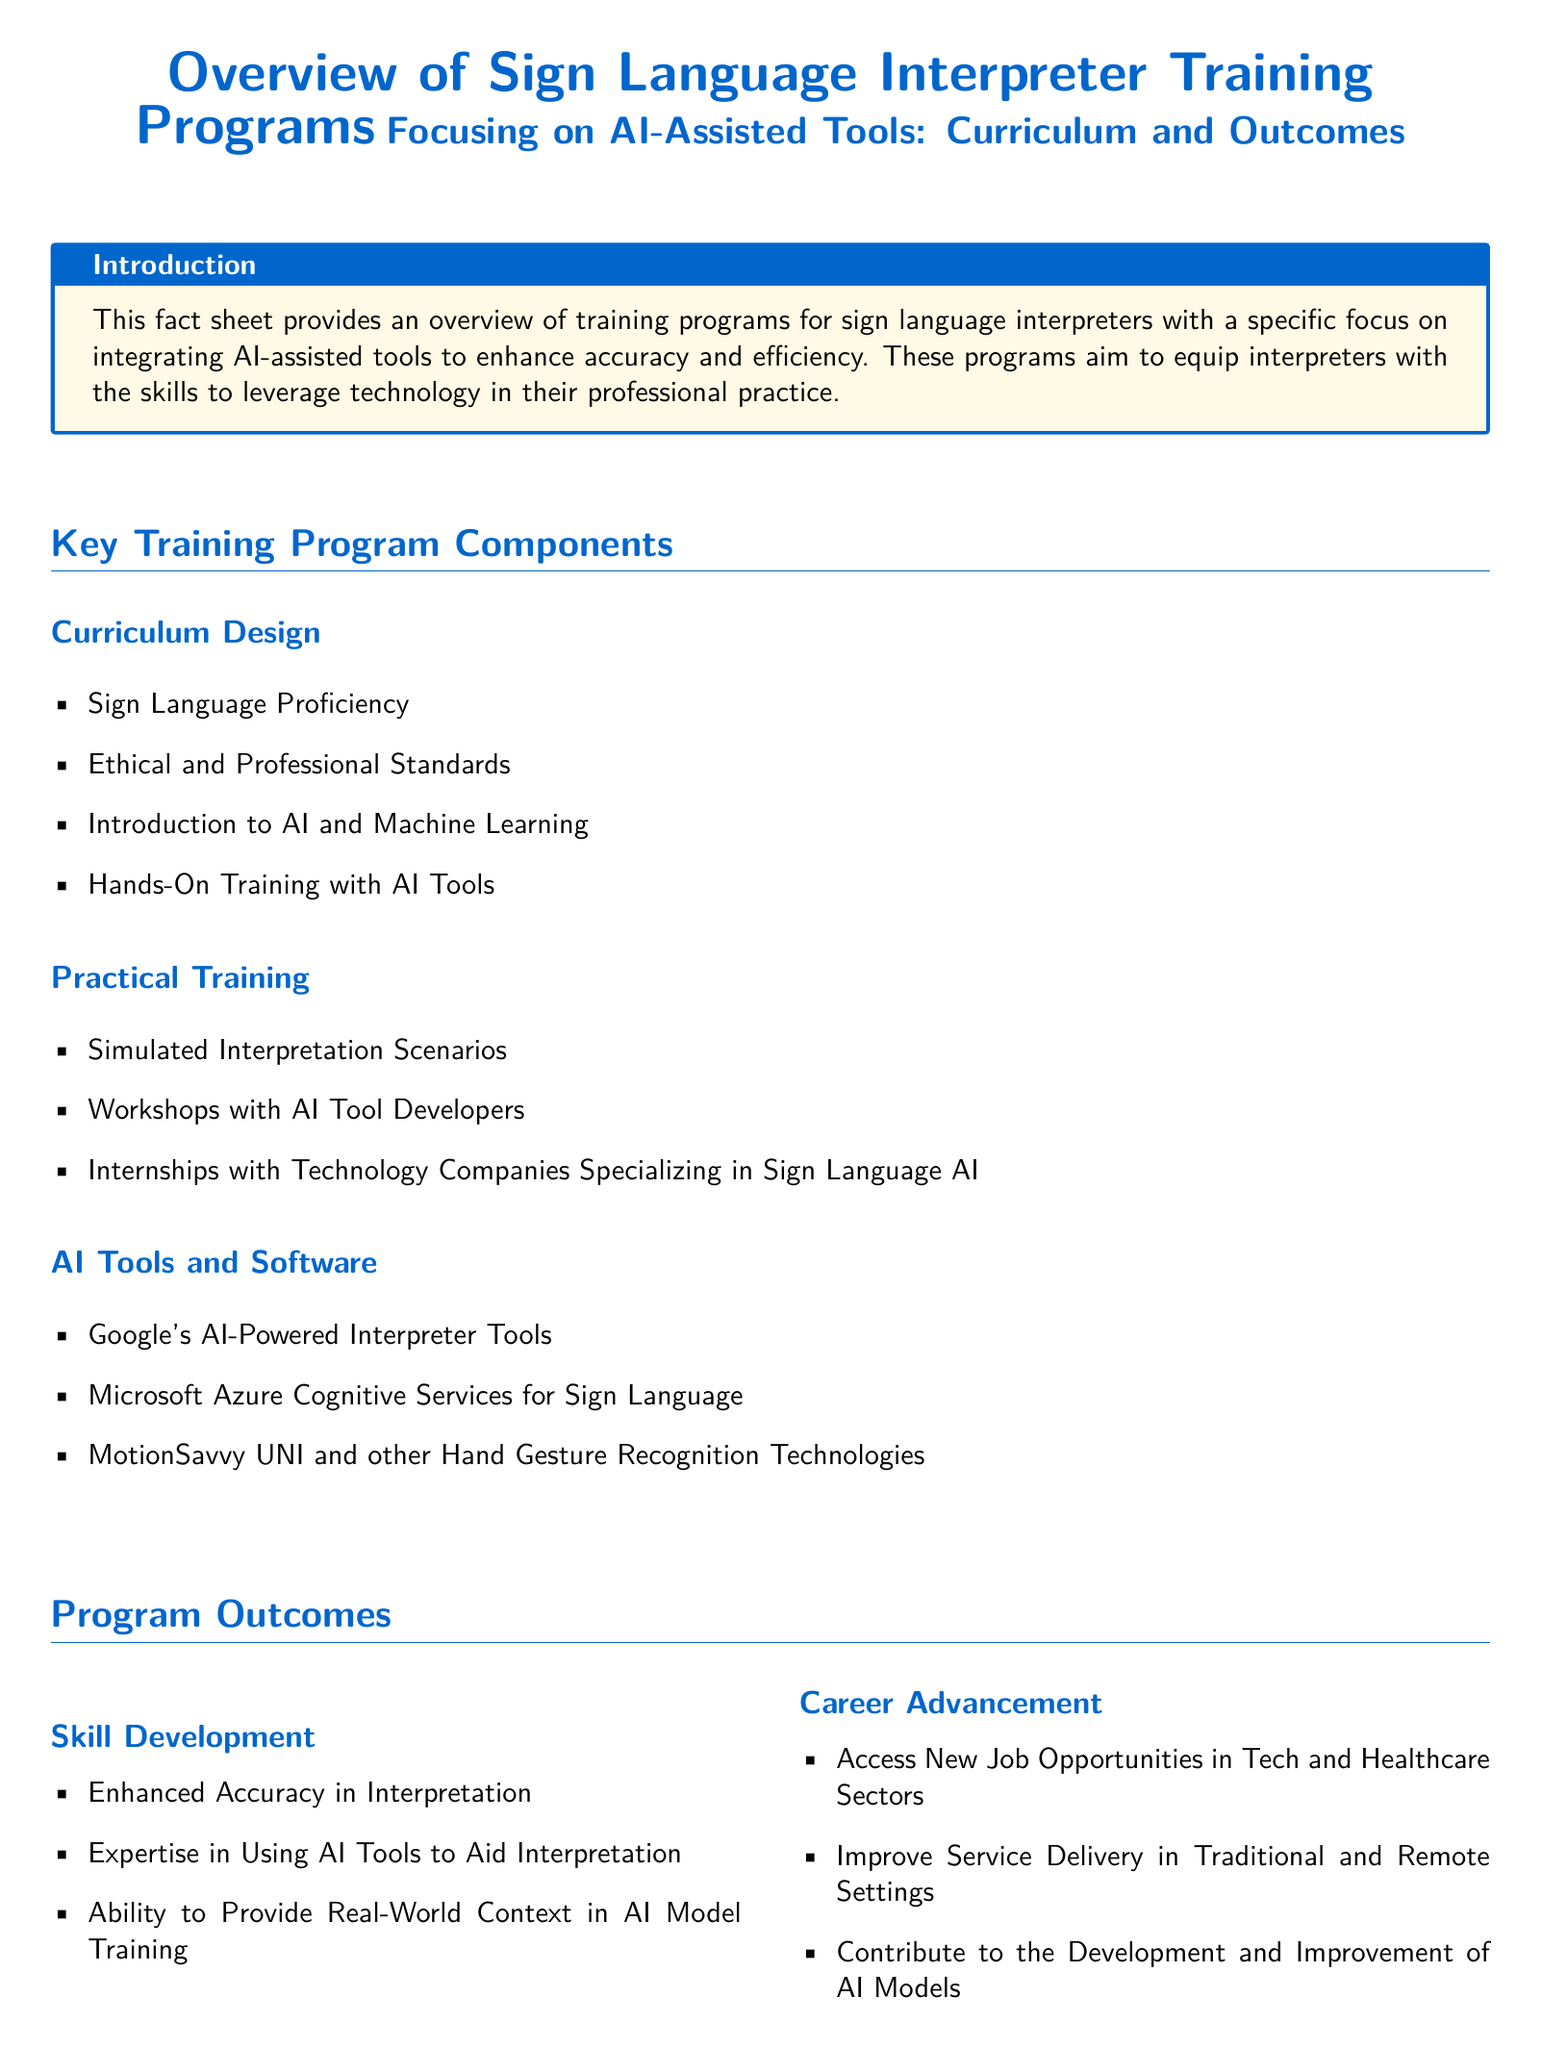What is the main focus of the training programs? The main focus is on integrating AI-assisted tools to enhance accuracy and efficiency.
Answer: AI-assisted tools How many key components are mentioned in the training programs? The section on key training program components outlines three specific areas.
Answer: Three Which university is mentioned as a real-world example? The document lists Gallaudet University's Center for Deaf Studies and Research as one of the real-world examples.
Answer: Gallaudet University What does the curriculum design include regarding ethical standards? The curriculum includes training on ethical and professional standards.
Answer: Ethical and professional standards What is one outcome of the programs related to skill development? The programs lead to enhanced accuracy in interpretation.
Answer: Enhanced accuracy in interpretation Which technology company’s services are mentioned in the AI tools section? Microsoft Azure Cognitive Services is listed as one of the AI tools and software mentioned.
Answer: Microsoft Azure Cognitive Services What type of training is included in the curriculum design? The curriculum design includes an introduction to AI and machine learning.
Answer: Introduction to AI and Machine Learning How do these programs contribute beyond skill enhancement? They contribute to the broader field of AI development.
Answer: AI development What specific internship opportunities are provided in the training programs? Internships with technology companies specializing in Sign Language AI are provided.
Answer: Technology companies specializing in Sign Language AI 